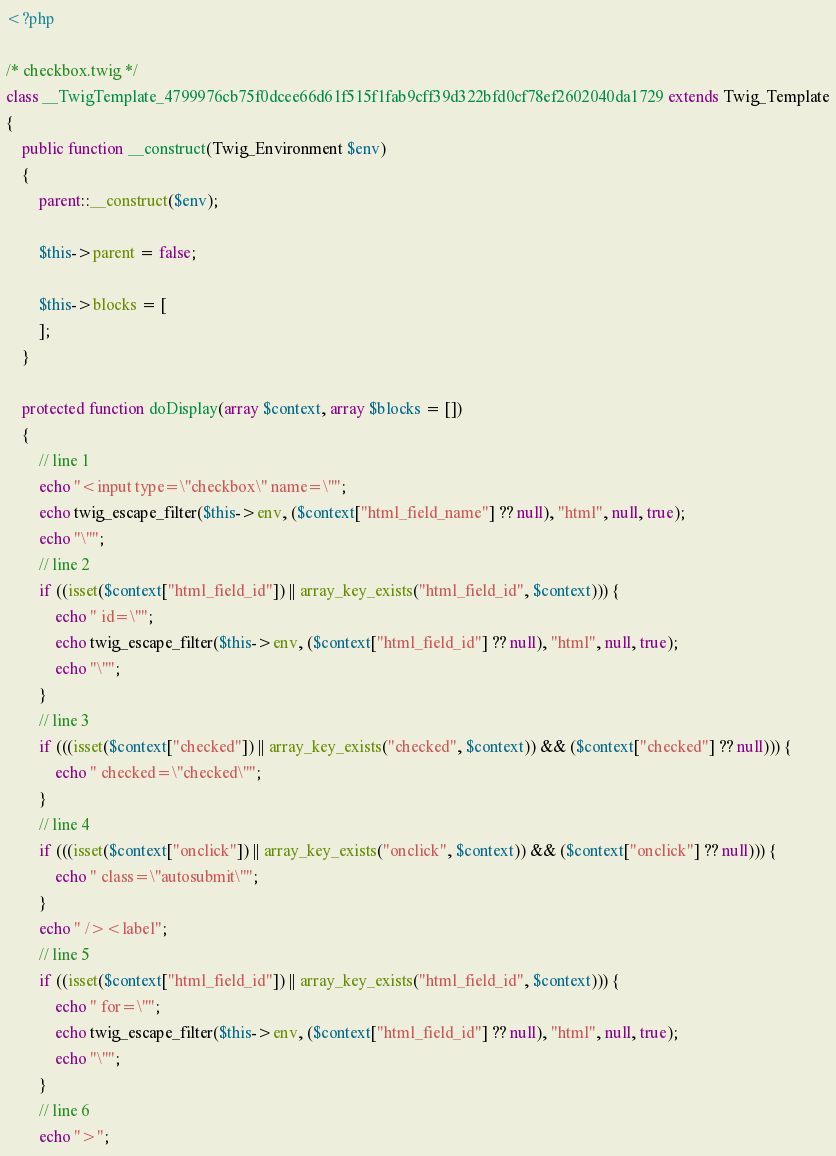Convert code to text. <code><loc_0><loc_0><loc_500><loc_500><_PHP_><?php

/* checkbox.twig */
class __TwigTemplate_4799976cb75f0dcee66d61f515f1fab9cff39d322bfd0cf78ef2602040da1729 extends Twig_Template
{
    public function __construct(Twig_Environment $env)
    {
        parent::__construct($env);

        $this->parent = false;

        $this->blocks = [
        ];
    }

    protected function doDisplay(array $context, array $blocks = [])
    {
        // line 1
        echo "<input type=\"checkbox\" name=\"";
        echo twig_escape_filter($this->env, ($context["html_field_name"] ?? null), "html", null, true);
        echo "\"";
        // line 2
        if ((isset($context["html_field_id"]) || array_key_exists("html_field_id", $context))) {
            echo " id=\"";
            echo twig_escape_filter($this->env, ($context["html_field_id"] ?? null), "html", null, true);
            echo "\"";
        }
        // line 3
        if (((isset($context["checked"]) || array_key_exists("checked", $context)) && ($context["checked"] ?? null))) {
            echo " checked=\"checked\"";
        }
        // line 4
        if (((isset($context["onclick"]) || array_key_exists("onclick", $context)) && ($context["onclick"] ?? null))) {
            echo " class=\"autosubmit\"";
        }
        echo " /><label";
        // line 5
        if ((isset($context["html_field_id"]) || array_key_exists("html_field_id", $context))) {
            echo " for=\"";
            echo twig_escape_filter($this->env, ($context["html_field_id"] ?? null), "html", null, true);
            echo "\"";
        }
        // line 6
        echo ">";</code> 